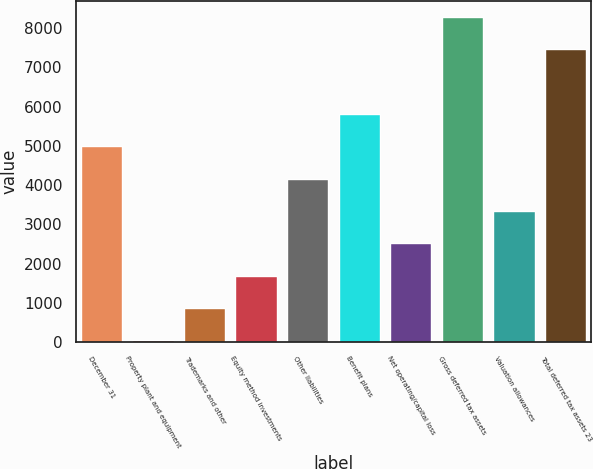Convert chart to OTSL. <chart><loc_0><loc_0><loc_500><loc_500><bar_chart><fcel>December 31<fcel>Property plant and equipment<fcel>Trademarks and other<fcel>Equity method investments<fcel>Other liabilities<fcel>Benefit plans<fcel>Net operating/capital loss<fcel>Gross deferred tax assets<fcel>Valuation allowances<fcel>Total deferred tax assets 23<nl><fcel>4984.6<fcel>49<fcel>871.6<fcel>1694.2<fcel>4162<fcel>5807.2<fcel>2516.8<fcel>8275<fcel>3339.4<fcel>7452.4<nl></chart> 